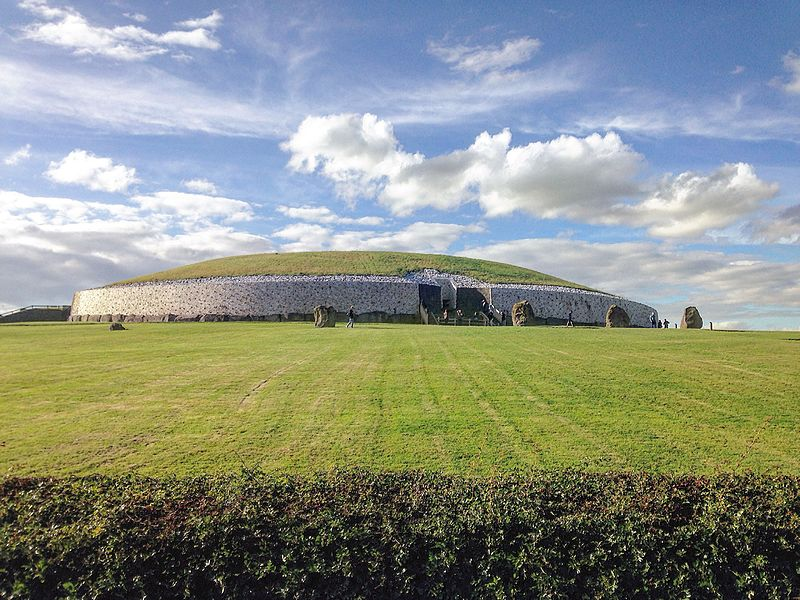What is this photo about? The image features Newgrange, a prehistoric monument in County Meath, Ireland, dating back to about 3200 BC. Prominently displayed is the large circular mound covered in grass, with a retaining wall at its base made of white quartz and granite stones. This site is not merely an archaeological curiosity; it holds great historical significance, aligning with the winter solstice sun, which illuminates its central chamber each year. Its imposing presence against a vibrant sky and the strategic arrangement of freestanding stones around it offer a glimpse into Neolithic engineering and religious practices. 